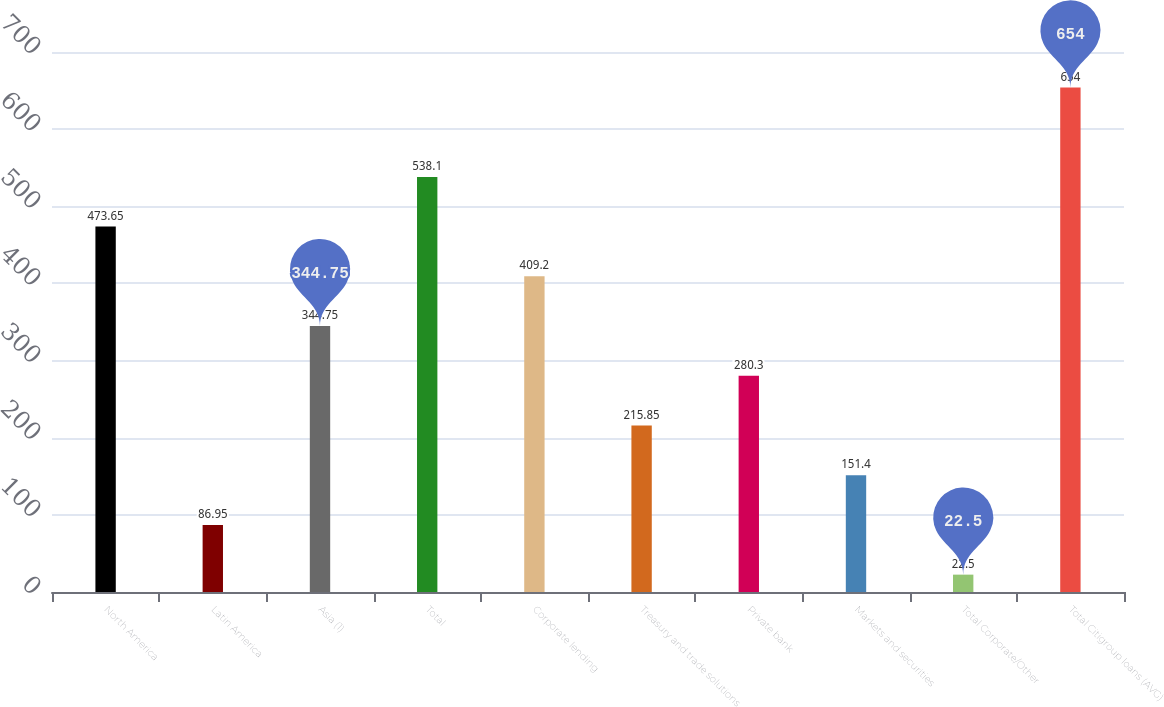<chart> <loc_0><loc_0><loc_500><loc_500><bar_chart><fcel>North America<fcel>Latin America<fcel>Asia (1)<fcel>Total<fcel>Corporate lending<fcel>Treasury and trade solutions<fcel>Private bank<fcel>Markets and securities<fcel>Total Corporate/Other<fcel>Total Citigroup loans (AVG)<nl><fcel>473.65<fcel>86.95<fcel>344.75<fcel>538.1<fcel>409.2<fcel>215.85<fcel>280.3<fcel>151.4<fcel>22.5<fcel>654<nl></chart> 